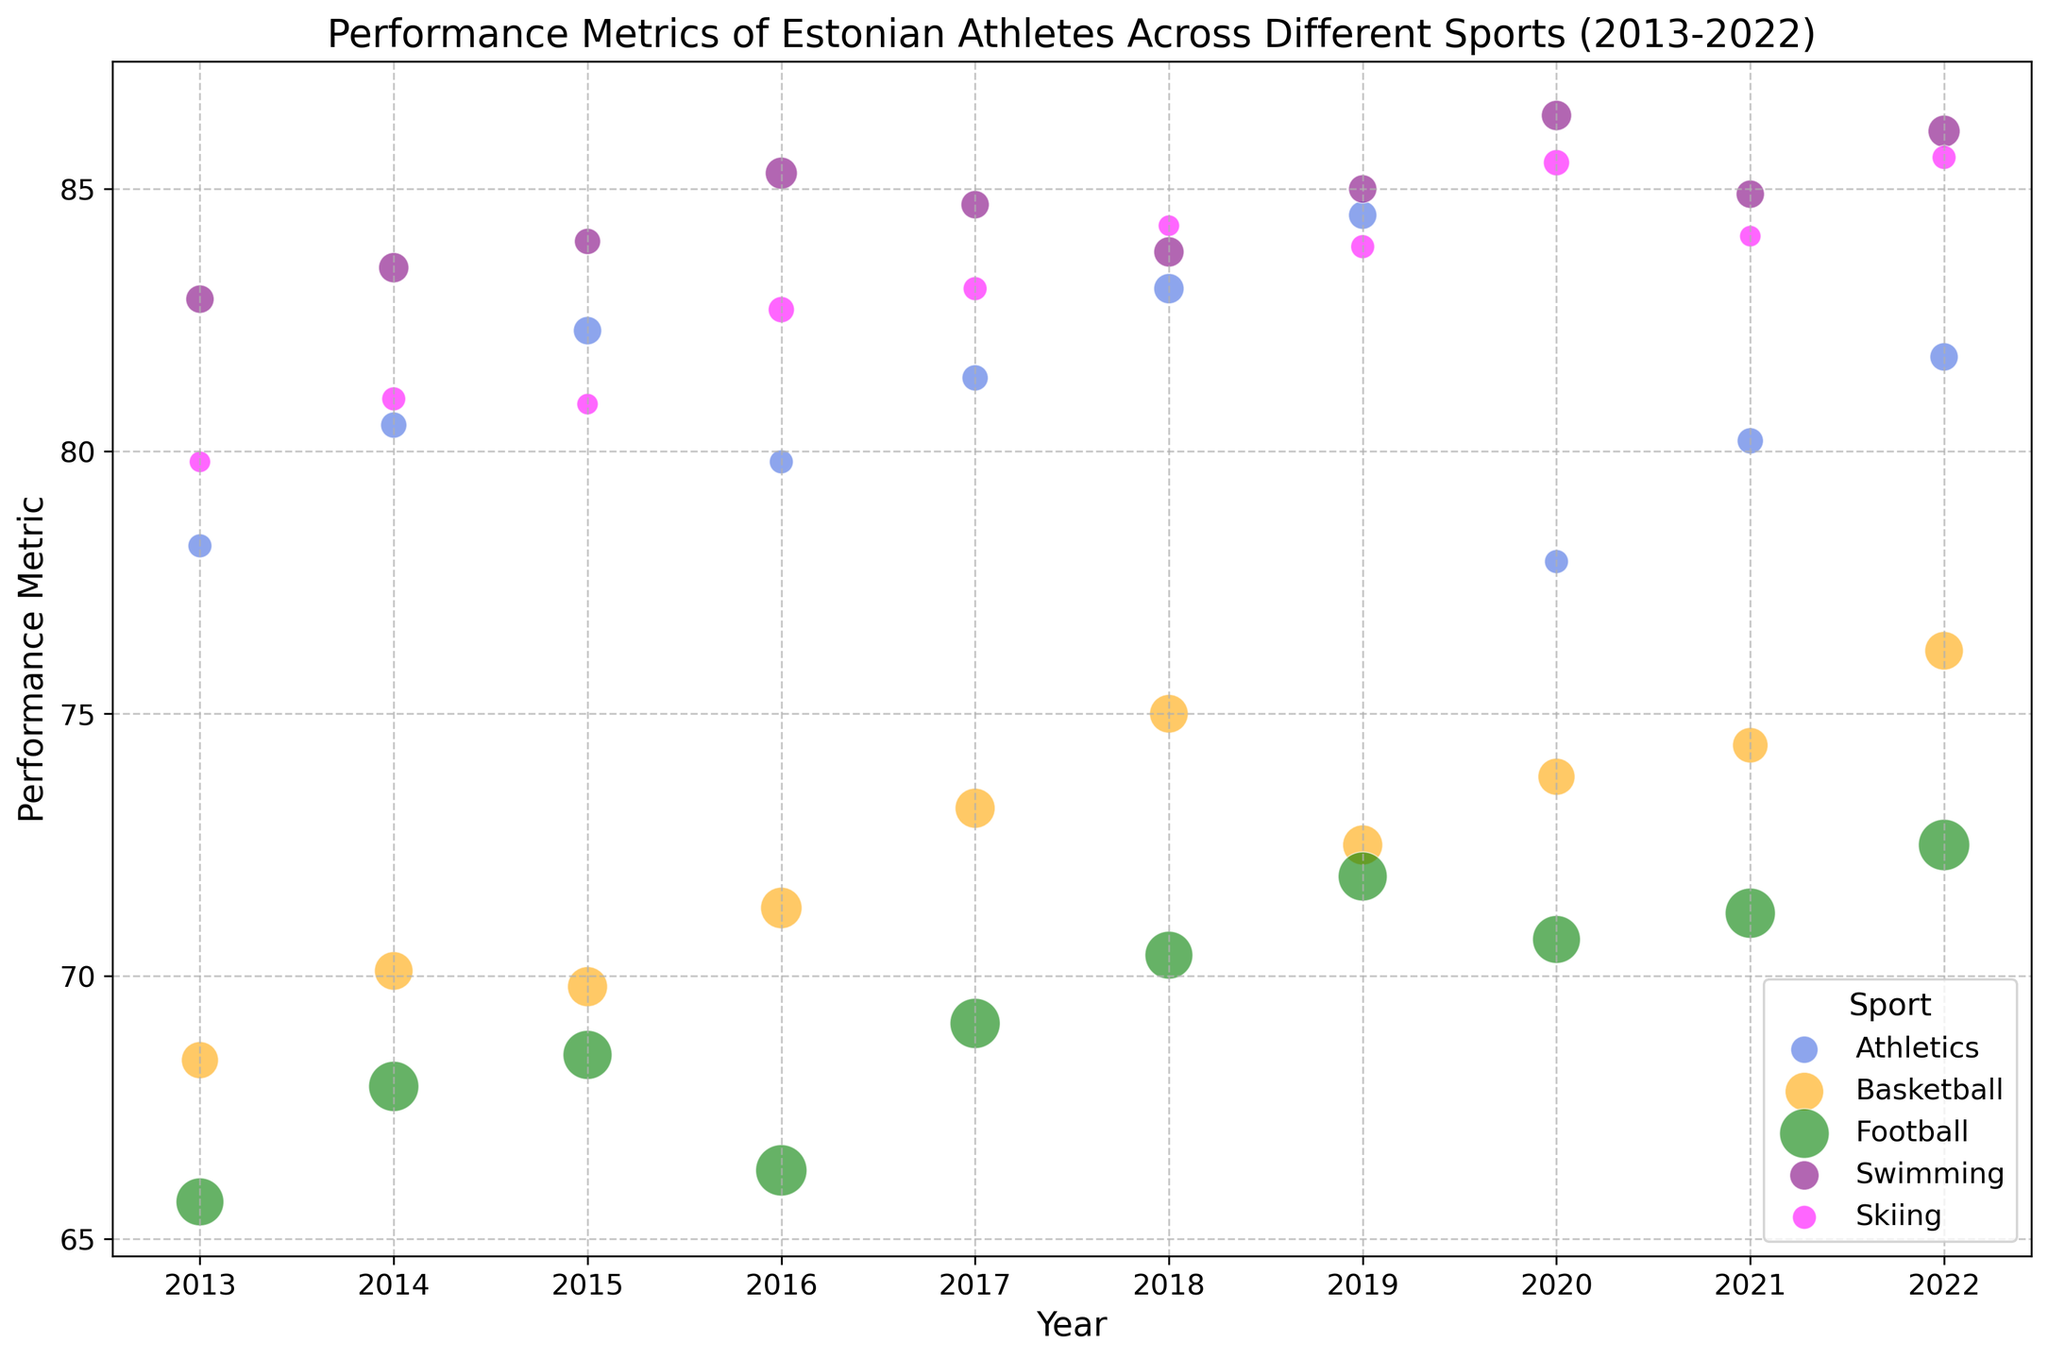What's the sport with the highest performance metric in 2022? The visual shows different sports with their performance metrics represented by the vertical position of the bubble. Observing the highest point in 2022, it corresponds to Swimming.
Answer: Swimming Which year had the lowest performance metric for Football? Look at the Football bubbles and identify the lowest vertical position. It is the year 2016 where the performance metric is lowest.
Answer: 2016 Comparing Athletics and Basketball, how many times did Basketball have a higher performance metric than Athletics between 2013 and 2022? Visually compare the vertical positions of the bubbles for each year from 2013 to 2022. Basketball bubbles are higher than Athletics in the years: 2017, 2020, and 2021.
Answer: 3 What was the average performance metric of Swimming in the decade? Calculate the arithmetic mean of the performance metrics for Swimming from 2013 to 2022: (82.9 + 83.5 + 84.0 + 85.3 + 84.7 + 83.8 + 85.0 + 86.4 + 84.9 + 86.1) / 10 = 84.66
Answer: 84.66 Which sport had the most athletes in 2019? By looking at the size of the bubbles in 2019, the largest bubble represents Football.
Answer: Football What is the trend in Athletics' performance over the decade? Observe the Athletics bubbles' vertical positions from 2013 to 2022, they show a slightly fluctuating trend but generally increasing performance.
Answer: Slightly increasing In which years did Swimming achieve a performance metric above 85? Identify the years where Swimming's bubbles are above the 85 mark, which are 2016, 2020, and 2022.
Answer: 2016, 2020, 2022 Which sport showed a significant performance improvement in 2018 compared to the previous year? Compare the vertical positions of bubbles from 2017 to 2018. The sport with a significant rise is Basketball.
Answer: Basketball 